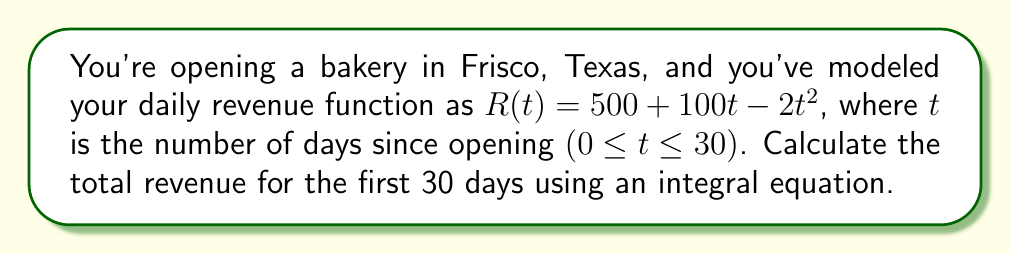Can you answer this question? To calculate the total revenue over the 30-day period, we need to integrate the revenue function $R(t)$ from $t=0$ to $t=30$. Here's how we do it:

1) Set up the integral:
   $$\int_0^{30} (500 + 100t - 2t^2) dt$$

2) Integrate each term:
   $$\left[500t + 50t^2 - \frac{2}{3}t^3\right]_0^{30}$$

3) Evaluate at the upper and lower bounds:
   $$\left(500(30) + 50(30)^2 - \frac{2}{3}(30)^3\right) - \left(500(0) + 50(0)^2 - \frac{2}{3}(0)^3\right)$$

4) Simplify:
   $$15000 + 45000 - 18000 - 0 = 42000$$

Therefore, the total revenue for the first 30 days is $42,000.
Answer: $42,000 